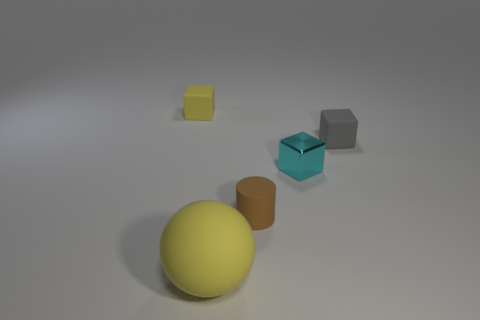Is there anything else that has the same size as the ball?
Provide a succinct answer. No. Are there any other things that have the same color as the shiny block?
Provide a succinct answer. No. What is the shape of the yellow matte thing that is in front of the small rubber block to the right of the large thing?
Ensure brevity in your answer.  Sphere. Does the brown cylinder have the same size as the matte thing in front of the small matte cylinder?
Provide a short and direct response. No. What is the size of the rubber cube that is left of the small rubber cylinder that is in front of the small block that is in front of the gray rubber block?
Give a very brief answer. Small. What number of things are either objects that are to the left of the small gray rubber thing or purple spheres?
Keep it short and to the point. 4. There is a rubber block left of the gray block; what number of yellow rubber balls are behind it?
Your response must be concise. 0. Is the number of yellow objects in front of the tiny brown thing greater than the number of big cyan shiny cubes?
Offer a very short reply. Yes. There is a rubber object that is both behind the brown object and right of the yellow ball; what size is it?
Your answer should be compact. Small. There is a thing that is both in front of the tiny gray block and on the left side of the small brown cylinder; what is its shape?
Provide a succinct answer. Sphere. 